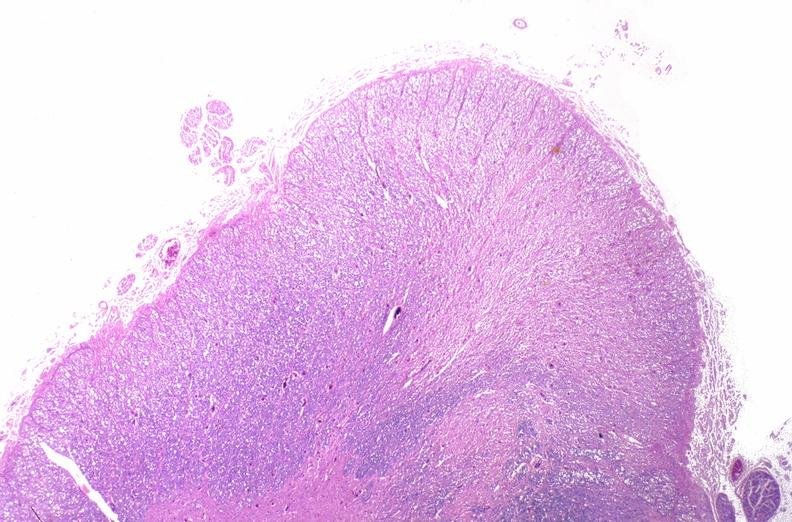s amyloid angiopathy r. endocrine present?
Answer the question using a single word or phrase. No 